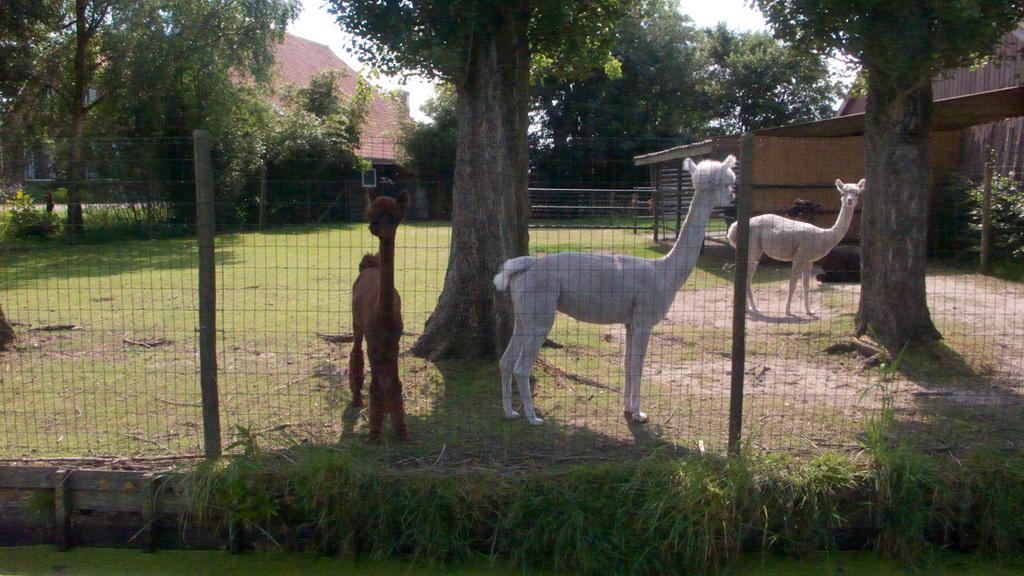What type of animals can be seen on the ground in the image? There are animals on the ground in the image, but their specific type is not mentioned in the facts. What type of vegetation is visible in the image? There is grass visible in the image, and trees are present as well. What kind of barrier is present in the image? There is a fence in the image. What part of the trees is visible in the image? The bark of trees is visible in the image. What type of structure is present in the image? There is a house with a roof in the image. What is visible in the sky in the image? The sky is visible in the image, and it appears cloudy. What type of cast can be seen in the image? There is no mention of a cast in the image. 